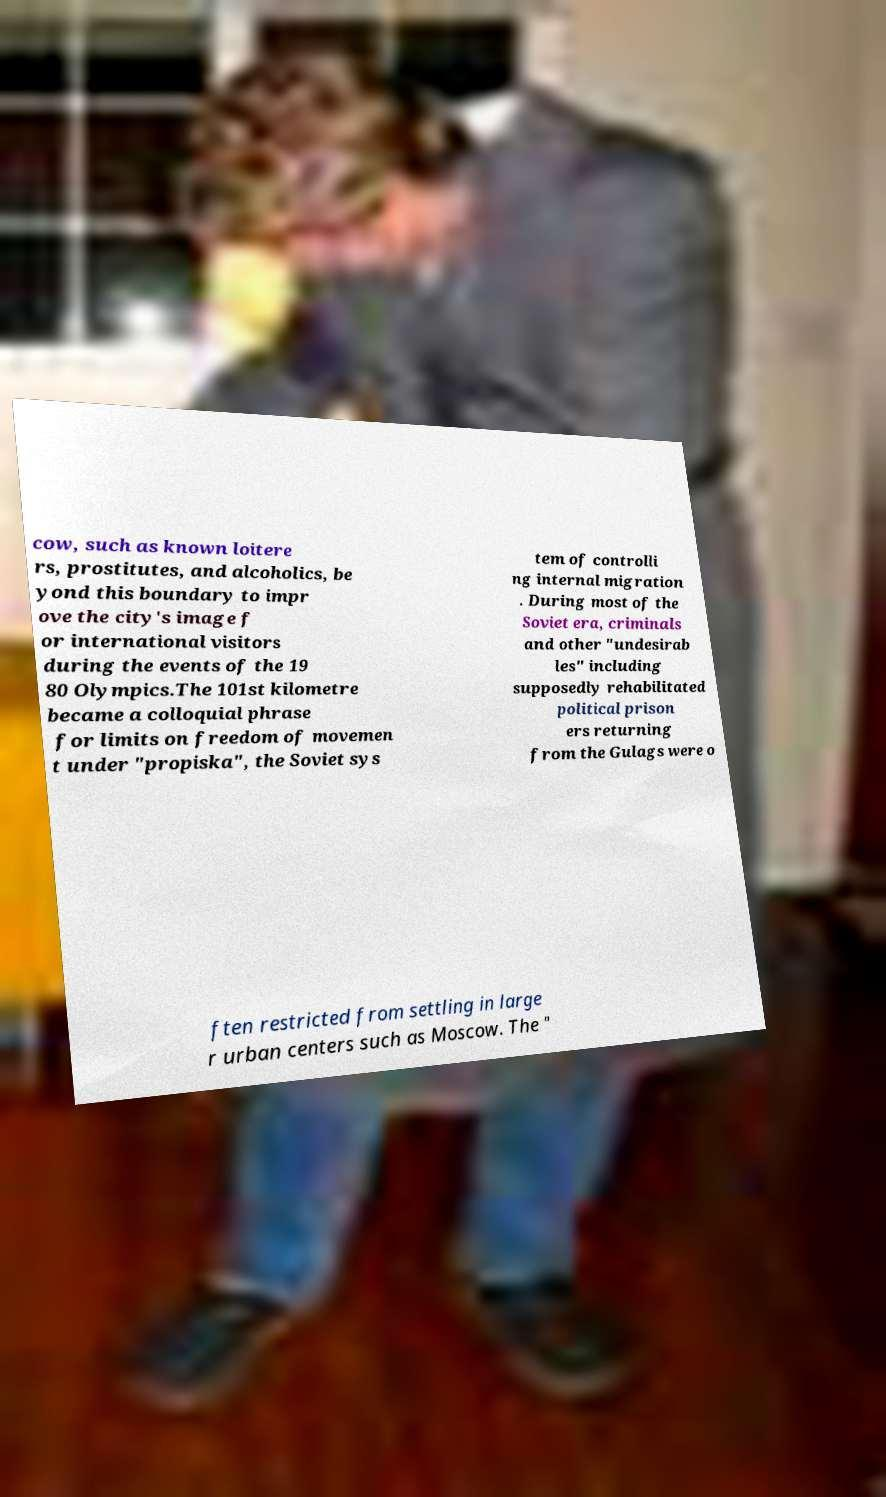Please identify and transcribe the text found in this image. cow, such as known loitere rs, prostitutes, and alcoholics, be yond this boundary to impr ove the city's image f or international visitors during the events of the 19 80 Olympics.The 101st kilometre became a colloquial phrase for limits on freedom of movemen t under "propiska", the Soviet sys tem of controlli ng internal migration . During most of the Soviet era, criminals and other "undesirab les" including supposedly rehabilitated political prison ers returning from the Gulags were o ften restricted from settling in large r urban centers such as Moscow. The " 